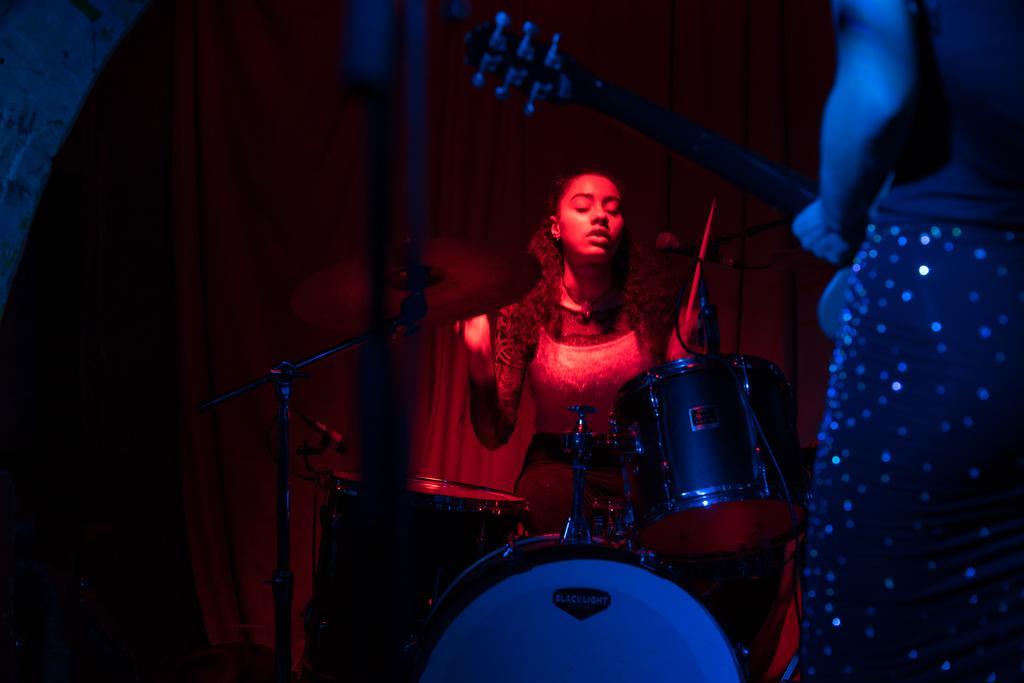Can you describe this image briefly? a person is standing at the right front , holding a guitar. at the back a person is playing drums. 